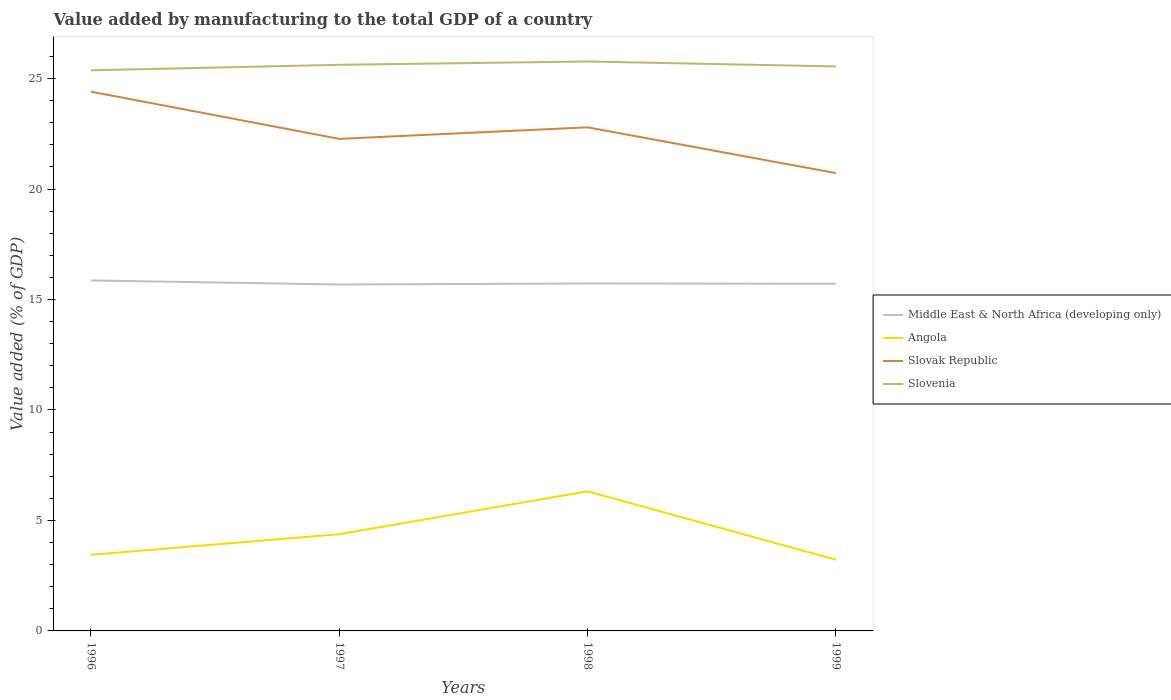Does the line corresponding to Angola intersect with the line corresponding to Slovenia?
Provide a short and direct response. No. Across all years, what is the maximum value added by manufacturing to the total GDP in Middle East & North Africa (developing only)?
Keep it short and to the point. 15.68. In which year was the value added by manufacturing to the total GDP in Slovenia maximum?
Your answer should be very brief. 1996. What is the total value added by manufacturing to the total GDP in Slovenia in the graph?
Provide a short and direct response. -0.15. What is the difference between the highest and the second highest value added by manufacturing to the total GDP in Angola?
Offer a very short reply. 3.1. What is the difference between the highest and the lowest value added by manufacturing to the total GDP in Middle East & North Africa (developing only)?
Your answer should be compact. 1. Is the value added by manufacturing to the total GDP in Slovak Republic strictly greater than the value added by manufacturing to the total GDP in Angola over the years?
Provide a short and direct response. No. How many lines are there?
Provide a short and direct response. 4. How many years are there in the graph?
Make the answer very short. 4. Are the values on the major ticks of Y-axis written in scientific E-notation?
Provide a succinct answer. No. Does the graph contain grids?
Ensure brevity in your answer.  No. How are the legend labels stacked?
Your answer should be compact. Vertical. What is the title of the graph?
Your answer should be very brief. Value added by manufacturing to the total GDP of a country. Does "Bermuda" appear as one of the legend labels in the graph?
Your response must be concise. No. What is the label or title of the Y-axis?
Your response must be concise. Value added (% of GDP). What is the Value added (% of GDP) in Middle East & North Africa (developing only) in 1996?
Provide a short and direct response. 15.86. What is the Value added (% of GDP) in Angola in 1996?
Your answer should be compact. 3.45. What is the Value added (% of GDP) in Slovak Republic in 1996?
Provide a succinct answer. 24.41. What is the Value added (% of GDP) of Slovenia in 1996?
Provide a short and direct response. 25.37. What is the Value added (% of GDP) of Middle East & North Africa (developing only) in 1997?
Ensure brevity in your answer.  15.68. What is the Value added (% of GDP) in Angola in 1997?
Your answer should be very brief. 4.38. What is the Value added (% of GDP) of Slovak Republic in 1997?
Offer a terse response. 22.27. What is the Value added (% of GDP) of Slovenia in 1997?
Provide a succinct answer. 25.62. What is the Value added (% of GDP) in Middle East & North Africa (developing only) in 1998?
Make the answer very short. 15.72. What is the Value added (% of GDP) of Angola in 1998?
Your answer should be very brief. 6.32. What is the Value added (% of GDP) in Slovak Republic in 1998?
Provide a succinct answer. 22.79. What is the Value added (% of GDP) in Slovenia in 1998?
Ensure brevity in your answer.  25.77. What is the Value added (% of GDP) in Middle East & North Africa (developing only) in 1999?
Your answer should be very brief. 15.71. What is the Value added (% of GDP) of Angola in 1999?
Your response must be concise. 3.22. What is the Value added (% of GDP) in Slovak Republic in 1999?
Provide a short and direct response. 20.72. What is the Value added (% of GDP) in Slovenia in 1999?
Offer a terse response. 25.55. Across all years, what is the maximum Value added (% of GDP) in Middle East & North Africa (developing only)?
Your response must be concise. 15.86. Across all years, what is the maximum Value added (% of GDP) in Angola?
Your answer should be very brief. 6.32. Across all years, what is the maximum Value added (% of GDP) in Slovak Republic?
Provide a succinct answer. 24.41. Across all years, what is the maximum Value added (% of GDP) of Slovenia?
Offer a terse response. 25.77. Across all years, what is the minimum Value added (% of GDP) in Middle East & North Africa (developing only)?
Keep it short and to the point. 15.68. Across all years, what is the minimum Value added (% of GDP) in Angola?
Ensure brevity in your answer.  3.22. Across all years, what is the minimum Value added (% of GDP) of Slovak Republic?
Ensure brevity in your answer.  20.72. Across all years, what is the minimum Value added (% of GDP) in Slovenia?
Give a very brief answer. 25.37. What is the total Value added (% of GDP) of Middle East & North Africa (developing only) in the graph?
Provide a short and direct response. 62.98. What is the total Value added (% of GDP) of Angola in the graph?
Provide a short and direct response. 17.37. What is the total Value added (% of GDP) of Slovak Republic in the graph?
Offer a terse response. 90.19. What is the total Value added (% of GDP) of Slovenia in the graph?
Offer a very short reply. 102.32. What is the difference between the Value added (% of GDP) of Middle East & North Africa (developing only) in 1996 and that in 1997?
Provide a short and direct response. 0.18. What is the difference between the Value added (% of GDP) in Angola in 1996 and that in 1997?
Your answer should be compact. -0.93. What is the difference between the Value added (% of GDP) in Slovak Republic in 1996 and that in 1997?
Offer a terse response. 2.14. What is the difference between the Value added (% of GDP) in Slovenia in 1996 and that in 1997?
Ensure brevity in your answer.  -0.25. What is the difference between the Value added (% of GDP) in Middle East & North Africa (developing only) in 1996 and that in 1998?
Keep it short and to the point. 0.14. What is the difference between the Value added (% of GDP) of Angola in 1996 and that in 1998?
Ensure brevity in your answer.  -2.87. What is the difference between the Value added (% of GDP) in Slovak Republic in 1996 and that in 1998?
Provide a short and direct response. 1.62. What is the difference between the Value added (% of GDP) in Slovenia in 1996 and that in 1998?
Give a very brief answer. -0.4. What is the difference between the Value added (% of GDP) in Middle East & North Africa (developing only) in 1996 and that in 1999?
Give a very brief answer. 0.15. What is the difference between the Value added (% of GDP) of Angola in 1996 and that in 1999?
Provide a succinct answer. 0.22. What is the difference between the Value added (% of GDP) in Slovak Republic in 1996 and that in 1999?
Give a very brief answer. 3.69. What is the difference between the Value added (% of GDP) in Slovenia in 1996 and that in 1999?
Ensure brevity in your answer.  -0.18. What is the difference between the Value added (% of GDP) in Middle East & North Africa (developing only) in 1997 and that in 1998?
Your answer should be compact. -0.05. What is the difference between the Value added (% of GDP) of Angola in 1997 and that in 1998?
Your answer should be compact. -1.94. What is the difference between the Value added (% of GDP) of Slovak Republic in 1997 and that in 1998?
Ensure brevity in your answer.  -0.52. What is the difference between the Value added (% of GDP) of Slovenia in 1997 and that in 1998?
Your answer should be very brief. -0.15. What is the difference between the Value added (% of GDP) in Middle East & North Africa (developing only) in 1997 and that in 1999?
Make the answer very short. -0.03. What is the difference between the Value added (% of GDP) of Angola in 1997 and that in 1999?
Make the answer very short. 1.16. What is the difference between the Value added (% of GDP) in Slovak Republic in 1997 and that in 1999?
Offer a very short reply. 1.55. What is the difference between the Value added (% of GDP) of Slovenia in 1997 and that in 1999?
Your response must be concise. 0.07. What is the difference between the Value added (% of GDP) in Middle East & North Africa (developing only) in 1998 and that in 1999?
Offer a very short reply. 0.01. What is the difference between the Value added (% of GDP) in Angola in 1998 and that in 1999?
Provide a succinct answer. 3.1. What is the difference between the Value added (% of GDP) of Slovak Republic in 1998 and that in 1999?
Offer a terse response. 2.07. What is the difference between the Value added (% of GDP) of Slovenia in 1998 and that in 1999?
Offer a very short reply. 0.22. What is the difference between the Value added (% of GDP) of Middle East & North Africa (developing only) in 1996 and the Value added (% of GDP) of Angola in 1997?
Make the answer very short. 11.48. What is the difference between the Value added (% of GDP) in Middle East & North Africa (developing only) in 1996 and the Value added (% of GDP) in Slovak Republic in 1997?
Provide a succinct answer. -6.41. What is the difference between the Value added (% of GDP) in Middle East & North Africa (developing only) in 1996 and the Value added (% of GDP) in Slovenia in 1997?
Ensure brevity in your answer.  -9.76. What is the difference between the Value added (% of GDP) in Angola in 1996 and the Value added (% of GDP) in Slovak Republic in 1997?
Your answer should be compact. -18.82. What is the difference between the Value added (% of GDP) of Angola in 1996 and the Value added (% of GDP) of Slovenia in 1997?
Your answer should be very brief. -22.18. What is the difference between the Value added (% of GDP) in Slovak Republic in 1996 and the Value added (% of GDP) in Slovenia in 1997?
Your answer should be very brief. -1.21. What is the difference between the Value added (% of GDP) in Middle East & North Africa (developing only) in 1996 and the Value added (% of GDP) in Angola in 1998?
Make the answer very short. 9.54. What is the difference between the Value added (% of GDP) of Middle East & North Africa (developing only) in 1996 and the Value added (% of GDP) of Slovak Republic in 1998?
Offer a very short reply. -6.93. What is the difference between the Value added (% of GDP) in Middle East & North Africa (developing only) in 1996 and the Value added (% of GDP) in Slovenia in 1998?
Ensure brevity in your answer.  -9.91. What is the difference between the Value added (% of GDP) of Angola in 1996 and the Value added (% of GDP) of Slovak Republic in 1998?
Make the answer very short. -19.35. What is the difference between the Value added (% of GDP) of Angola in 1996 and the Value added (% of GDP) of Slovenia in 1998?
Keep it short and to the point. -22.33. What is the difference between the Value added (% of GDP) of Slovak Republic in 1996 and the Value added (% of GDP) of Slovenia in 1998?
Your response must be concise. -1.36. What is the difference between the Value added (% of GDP) of Middle East & North Africa (developing only) in 1996 and the Value added (% of GDP) of Angola in 1999?
Provide a succinct answer. 12.64. What is the difference between the Value added (% of GDP) in Middle East & North Africa (developing only) in 1996 and the Value added (% of GDP) in Slovak Republic in 1999?
Provide a succinct answer. -4.86. What is the difference between the Value added (% of GDP) of Middle East & North Africa (developing only) in 1996 and the Value added (% of GDP) of Slovenia in 1999?
Offer a very short reply. -9.69. What is the difference between the Value added (% of GDP) of Angola in 1996 and the Value added (% of GDP) of Slovak Republic in 1999?
Offer a very short reply. -17.28. What is the difference between the Value added (% of GDP) in Angola in 1996 and the Value added (% of GDP) in Slovenia in 1999?
Keep it short and to the point. -22.1. What is the difference between the Value added (% of GDP) in Slovak Republic in 1996 and the Value added (% of GDP) in Slovenia in 1999?
Provide a succinct answer. -1.14. What is the difference between the Value added (% of GDP) in Middle East & North Africa (developing only) in 1997 and the Value added (% of GDP) in Angola in 1998?
Your response must be concise. 9.36. What is the difference between the Value added (% of GDP) in Middle East & North Africa (developing only) in 1997 and the Value added (% of GDP) in Slovak Republic in 1998?
Your response must be concise. -7.11. What is the difference between the Value added (% of GDP) in Middle East & North Africa (developing only) in 1997 and the Value added (% of GDP) in Slovenia in 1998?
Provide a short and direct response. -10.09. What is the difference between the Value added (% of GDP) of Angola in 1997 and the Value added (% of GDP) of Slovak Republic in 1998?
Provide a succinct answer. -18.41. What is the difference between the Value added (% of GDP) of Angola in 1997 and the Value added (% of GDP) of Slovenia in 1998?
Offer a terse response. -21.39. What is the difference between the Value added (% of GDP) in Slovak Republic in 1997 and the Value added (% of GDP) in Slovenia in 1998?
Keep it short and to the point. -3.5. What is the difference between the Value added (% of GDP) of Middle East & North Africa (developing only) in 1997 and the Value added (% of GDP) of Angola in 1999?
Offer a terse response. 12.46. What is the difference between the Value added (% of GDP) of Middle East & North Africa (developing only) in 1997 and the Value added (% of GDP) of Slovak Republic in 1999?
Offer a terse response. -5.04. What is the difference between the Value added (% of GDP) in Middle East & North Africa (developing only) in 1997 and the Value added (% of GDP) in Slovenia in 1999?
Your response must be concise. -9.87. What is the difference between the Value added (% of GDP) in Angola in 1997 and the Value added (% of GDP) in Slovak Republic in 1999?
Your answer should be compact. -16.34. What is the difference between the Value added (% of GDP) of Angola in 1997 and the Value added (% of GDP) of Slovenia in 1999?
Offer a very short reply. -21.17. What is the difference between the Value added (% of GDP) of Slovak Republic in 1997 and the Value added (% of GDP) of Slovenia in 1999?
Provide a succinct answer. -3.28. What is the difference between the Value added (% of GDP) of Middle East & North Africa (developing only) in 1998 and the Value added (% of GDP) of Angola in 1999?
Provide a succinct answer. 12.5. What is the difference between the Value added (% of GDP) in Middle East & North Africa (developing only) in 1998 and the Value added (% of GDP) in Slovak Republic in 1999?
Offer a very short reply. -5. What is the difference between the Value added (% of GDP) of Middle East & North Africa (developing only) in 1998 and the Value added (% of GDP) of Slovenia in 1999?
Keep it short and to the point. -9.82. What is the difference between the Value added (% of GDP) of Angola in 1998 and the Value added (% of GDP) of Slovak Republic in 1999?
Keep it short and to the point. -14.4. What is the difference between the Value added (% of GDP) in Angola in 1998 and the Value added (% of GDP) in Slovenia in 1999?
Offer a very short reply. -19.23. What is the difference between the Value added (% of GDP) of Slovak Republic in 1998 and the Value added (% of GDP) of Slovenia in 1999?
Keep it short and to the point. -2.76. What is the average Value added (% of GDP) in Middle East & North Africa (developing only) per year?
Your response must be concise. 15.75. What is the average Value added (% of GDP) in Angola per year?
Your response must be concise. 4.34. What is the average Value added (% of GDP) in Slovak Republic per year?
Offer a terse response. 22.55. What is the average Value added (% of GDP) of Slovenia per year?
Provide a succinct answer. 25.58. In the year 1996, what is the difference between the Value added (% of GDP) in Middle East & North Africa (developing only) and Value added (% of GDP) in Angola?
Your response must be concise. 12.42. In the year 1996, what is the difference between the Value added (% of GDP) in Middle East & North Africa (developing only) and Value added (% of GDP) in Slovak Republic?
Give a very brief answer. -8.55. In the year 1996, what is the difference between the Value added (% of GDP) in Middle East & North Africa (developing only) and Value added (% of GDP) in Slovenia?
Offer a terse response. -9.51. In the year 1996, what is the difference between the Value added (% of GDP) of Angola and Value added (% of GDP) of Slovak Republic?
Keep it short and to the point. -20.96. In the year 1996, what is the difference between the Value added (% of GDP) of Angola and Value added (% of GDP) of Slovenia?
Keep it short and to the point. -21.93. In the year 1996, what is the difference between the Value added (% of GDP) of Slovak Republic and Value added (% of GDP) of Slovenia?
Ensure brevity in your answer.  -0.96. In the year 1997, what is the difference between the Value added (% of GDP) in Middle East & North Africa (developing only) and Value added (% of GDP) in Angola?
Make the answer very short. 11.3. In the year 1997, what is the difference between the Value added (% of GDP) of Middle East & North Africa (developing only) and Value added (% of GDP) of Slovak Republic?
Make the answer very short. -6.59. In the year 1997, what is the difference between the Value added (% of GDP) in Middle East & North Africa (developing only) and Value added (% of GDP) in Slovenia?
Provide a succinct answer. -9.94. In the year 1997, what is the difference between the Value added (% of GDP) of Angola and Value added (% of GDP) of Slovak Republic?
Your response must be concise. -17.89. In the year 1997, what is the difference between the Value added (% of GDP) in Angola and Value added (% of GDP) in Slovenia?
Keep it short and to the point. -21.24. In the year 1997, what is the difference between the Value added (% of GDP) of Slovak Republic and Value added (% of GDP) of Slovenia?
Offer a terse response. -3.35. In the year 1998, what is the difference between the Value added (% of GDP) of Middle East & North Africa (developing only) and Value added (% of GDP) of Angola?
Offer a very short reply. 9.41. In the year 1998, what is the difference between the Value added (% of GDP) of Middle East & North Africa (developing only) and Value added (% of GDP) of Slovak Republic?
Provide a succinct answer. -7.07. In the year 1998, what is the difference between the Value added (% of GDP) of Middle East & North Africa (developing only) and Value added (% of GDP) of Slovenia?
Provide a short and direct response. -10.05. In the year 1998, what is the difference between the Value added (% of GDP) in Angola and Value added (% of GDP) in Slovak Republic?
Ensure brevity in your answer.  -16.47. In the year 1998, what is the difference between the Value added (% of GDP) in Angola and Value added (% of GDP) in Slovenia?
Give a very brief answer. -19.45. In the year 1998, what is the difference between the Value added (% of GDP) of Slovak Republic and Value added (% of GDP) of Slovenia?
Make the answer very short. -2.98. In the year 1999, what is the difference between the Value added (% of GDP) in Middle East & North Africa (developing only) and Value added (% of GDP) in Angola?
Make the answer very short. 12.49. In the year 1999, what is the difference between the Value added (% of GDP) in Middle East & North Africa (developing only) and Value added (% of GDP) in Slovak Republic?
Offer a terse response. -5.01. In the year 1999, what is the difference between the Value added (% of GDP) in Middle East & North Africa (developing only) and Value added (% of GDP) in Slovenia?
Your response must be concise. -9.83. In the year 1999, what is the difference between the Value added (% of GDP) of Angola and Value added (% of GDP) of Slovak Republic?
Keep it short and to the point. -17.5. In the year 1999, what is the difference between the Value added (% of GDP) in Angola and Value added (% of GDP) in Slovenia?
Provide a short and direct response. -22.33. In the year 1999, what is the difference between the Value added (% of GDP) in Slovak Republic and Value added (% of GDP) in Slovenia?
Offer a terse response. -4.83. What is the ratio of the Value added (% of GDP) of Middle East & North Africa (developing only) in 1996 to that in 1997?
Give a very brief answer. 1.01. What is the ratio of the Value added (% of GDP) of Angola in 1996 to that in 1997?
Ensure brevity in your answer.  0.79. What is the ratio of the Value added (% of GDP) of Slovak Republic in 1996 to that in 1997?
Your answer should be compact. 1.1. What is the ratio of the Value added (% of GDP) of Slovenia in 1996 to that in 1997?
Your answer should be very brief. 0.99. What is the ratio of the Value added (% of GDP) of Middle East & North Africa (developing only) in 1996 to that in 1998?
Ensure brevity in your answer.  1.01. What is the ratio of the Value added (% of GDP) of Angola in 1996 to that in 1998?
Offer a very short reply. 0.55. What is the ratio of the Value added (% of GDP) in Slovak Republic in 1996 to that in 1998?
Offer a very short reply. 1.07. What is the ratio of the Value added (% of GDP) of Slovenia in 1996 to that in 1998?
Offer a terse response. 0.98. What is the ratio of the Value added (% of GDP) of Middle East & North Africa (developing only) in 1996 to that in 1999?
Provide a short and direct response. 1.01. What is the ratio of the Value added (% of GDP) of Angola in 1996 to that in 1999?
Keep it short and to the point. 1.07. What is the ratio of the Value added (% of GDP) of Slovak Republic in 1996 to that in 1999?
Provide a succinct answer. 1.18. What is the ratio of the Value added (% of GDP) of Slovenia in 1996 to that in 1999?
Your answer should be very brief. 0.99. What is the ratio of the Value added (% of GDP) in Middle East & North Africa (developing only) in 1997 to that in 1998?
Offer a very short reply. 1. What is the ratio of the Value added (% of GDP) of Angola in 1997 to that in 1998?
Provide a succinct answer. 0.69. What is the ratio of the Value added (% of GDP) in Slovak Republic in 1997 to that in 1998?
Provide a short and direct response. 0.98. What is the ratio of the Value added (% of GDP) of Angola in 1997 to that in 1999?
Provide a succinct answer. 1.36. What is the ratio of the Value added (% of GDP) of Slovak Republic in 1997 to that in 1999?
Your response must be concise. 1.07. What is the ratio of the Value added (% of GDP) of Angola in 1998 to that in 1999?
Offer a terse response. 1.96. What is the ratio of the Value added (% of GDP) of Slovenia in 1998 to that in 1999?
Keep it short and to the point. 1.01. What is the difference between the highest and the second highest Value added (% of GDP) of Middle East & North Africa (developing only)?
Offer a very short reply. 0.14. What is the difference between the highest and the second highest Value added (% of GDP) in Angola?
Your answer should be very brief. 1.94. What is the difference between the highest and the second highest Value added (% of GDP) of Slovak Republic?
Keep it short and to the point. 1.62. What is the difference between the highest and the second highest Value added (% of GDP) in Slovenia?
Your answer should be very brief. 0.15. What is the difference between the highest and the lowest Value added (% of GDP) of Middle East & North Africa (developing only)?
Your response must be concise. 0.18. What is the difference between the highest and the lowest Value added (% of GDP) in Angola?
Your answer should be very brief. 3.1. What is the difference between the highest and the lowest Value added (% of GDP) of Slovak Republic?
Make the answer very short. 3.69. What is the difference between the highest and the lowest Value added (% of GDP) of Slovenia?
Your answer should be very brief. 0.4. 